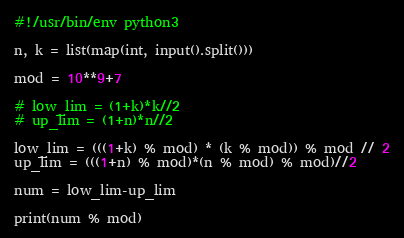Convert code to text. <code><loc_0><loc_0><loc_500><loc_500><_Python_>#!/usr/bin/env python3

n, k = list(map(int, input().split()))

mod = 10**9+7

# low_lim = (1+k)*k//2
# up_lim = (1+n)*n//2

low_lim = (((1+k) % mod) * (k % mod)) % mod // 2
up_lim = (((1+n) % mod)*(n % mod) % mod)//2

num = low_lim-up_lim

print(num % mod)
</code> 